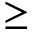<formula> <loc_0><loc_0><loc_500><loc_500>\geq</formula> 